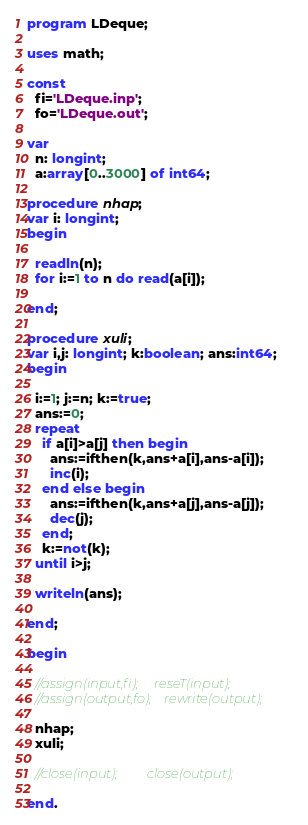<code> <loc_0><loc_0><loc_500><loc_500><_Pascal_>program LDeque;

uses math;

const
  fi='LDeque.inp';
  fo='LDeque.out';

var
  n: longint;
  a:array[0..3000] of int64;

procedure nhap;
var i: longint;
begin

  readln(n);
  for i:=1 to n do read(a[i]);

end;

procedure xuli;
var i,j: longint; k:boolean; ans:int64;
begin

  i:=1; j:=n; k:=true;
  ans:=0;
  repeat
    if a[i]>a[j] then begin
      ans:=ifthen(k,ans+a[i],ans-a[i]);
      inc(i);
    end else begin
      ans:=ifthen(k,ans+a[j],ans-a[j]);
      dec(j);
    end;
    k:=not(k);
  until i>j;

  writeln(ans);

end;

begin

  //assign(input,fi);     reseT(input);
  //assign(output,fo);    rewrite(output);

  nhap;
  xuli;

  //close(input);         close(output);

end.
</code> 